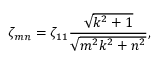<formula> <loc_0><loc_0><loc_500><loc_500>\zeta _ { m n } = \zeta _ { 1 1 } \frac { \sqrt { k ^ { 2 } + 1 } } { \sqrt { m ^ { 2 } k ^ { 2 } + n ^ { 2 } } } ,</formula> 